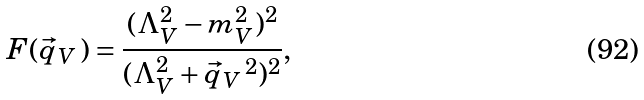Convert formula to latex. <formula><loc_0><loc_0><loc_500><loc_500>F ( \vec { q } _ { V } \, ) = \frac { ( \Lambda _ { V } ^ { 2 } - m _ { V } ^ { 2 } ) ^ { 2 } } { ( \Lambda _ { V } ^ { 2 } + \vec { q } _ { V } \, ^ { 2 } ) ^ { 2 } } ,</formula> 